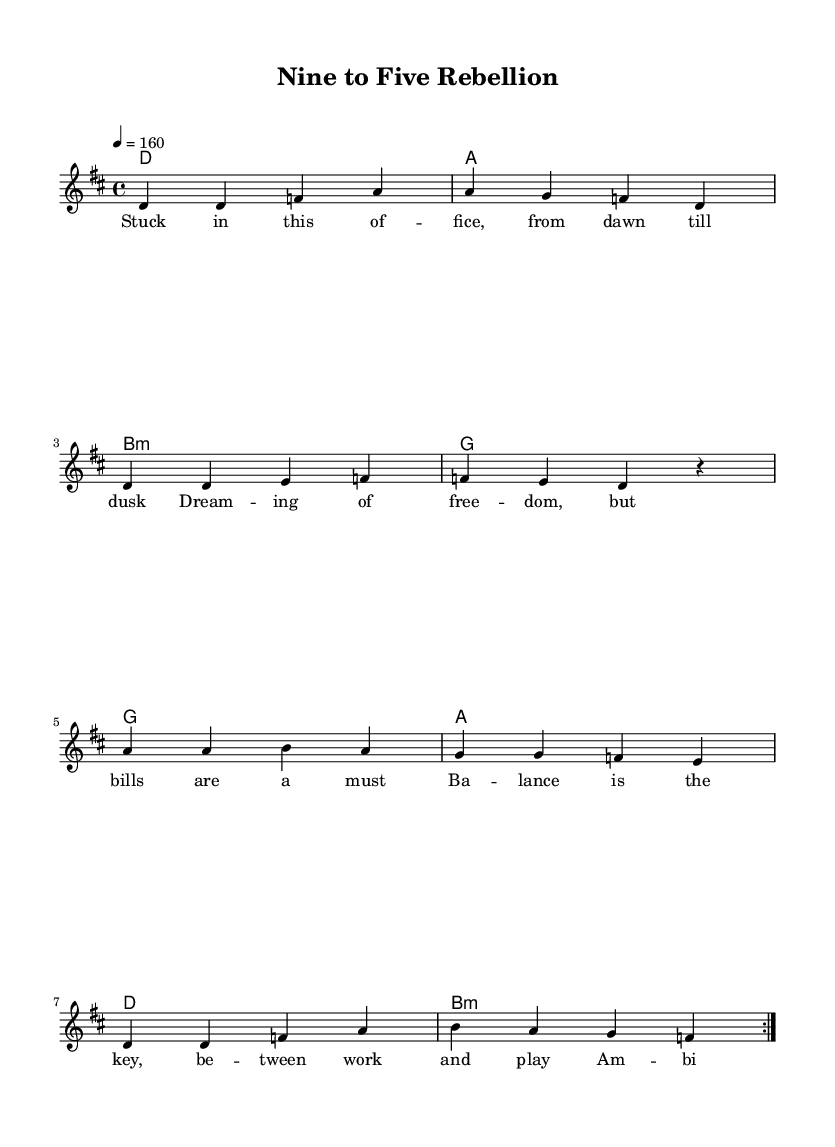What is the key signature of this music? The key signature indicates there are two sharps, which corresponds to the key of D major.
Answer: D major What is the time signature of this piece? The time signature is indicated by the numbers at the beginning of the score, which specify 4 beats per measure.
Answer: 4/4 What is the tempo marking for this composition? The tempo marking shows "4 = 160," indicating a lively pace of 160 beats per minute.
Answer: 160 How many times is the melody repeated? The repeated sections are indicated by "volta," which shows the melody is played twice in succession.
Answer: 2 What are the first two lyrics of the verse? The lyrics in the verse begin with "Stuck in this of -- fice," thus showing the initial words of the song.
Answer: Stuck in this of -- fice What is the last chord in the harmony progression? By examining the chord progression at the end of the sequence, the last chord is a B minor chord, as indicated in the score.
Answer: B minor What theme does the song's lyrics primarily address? The song's lyrical content directly addresses the struggle of balancing work and personal life, depicting ambition versus personal freedom.
Answer: Work-life balance 